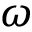<formula> <loc_0><loc_0><loc_500><loc_500>\omega</formula> 